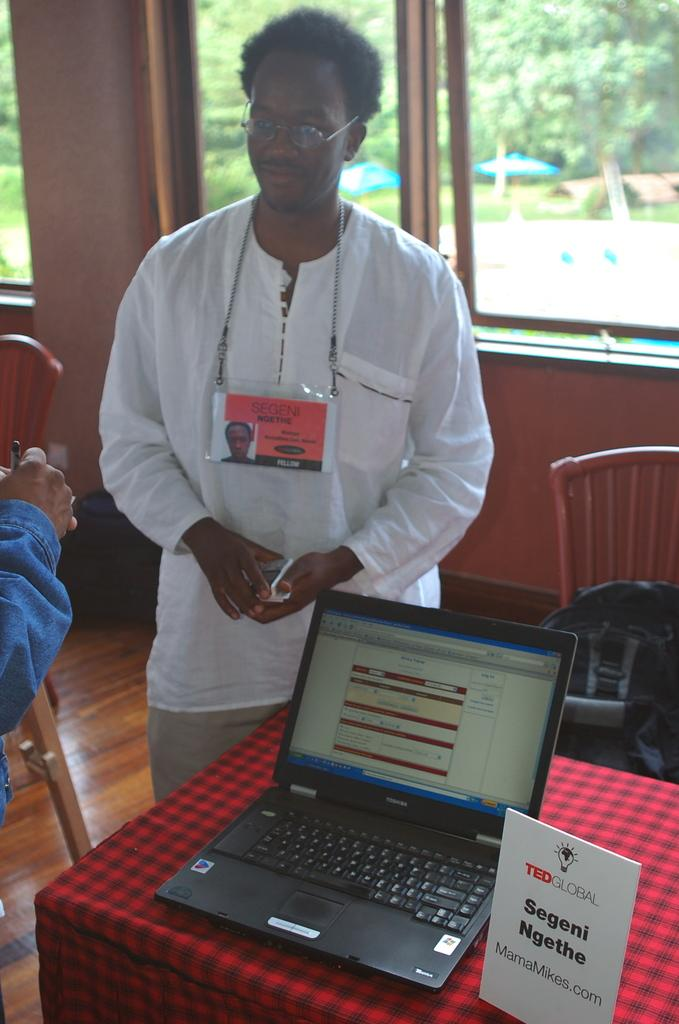What is the main subject of the picture? There is a man in the picture. What is the man doing in the image? The man is standing beside a table. Are there any other people in the image? Yes, there is another man standing beside the table. What object is on the table? There is a laptop on the table. What can be seen in the background of the image? There are chairs and a glass window on the wall in the background. What type of liquid is being poured from the glass window in the image? There is no liquid being poured from the glass window in the image; it is a solid structure made of glass. What type of skin is visible on the man's hands in the image? There is no specific detail about the man's skin visible in the image, as it is not the focus of the image. 